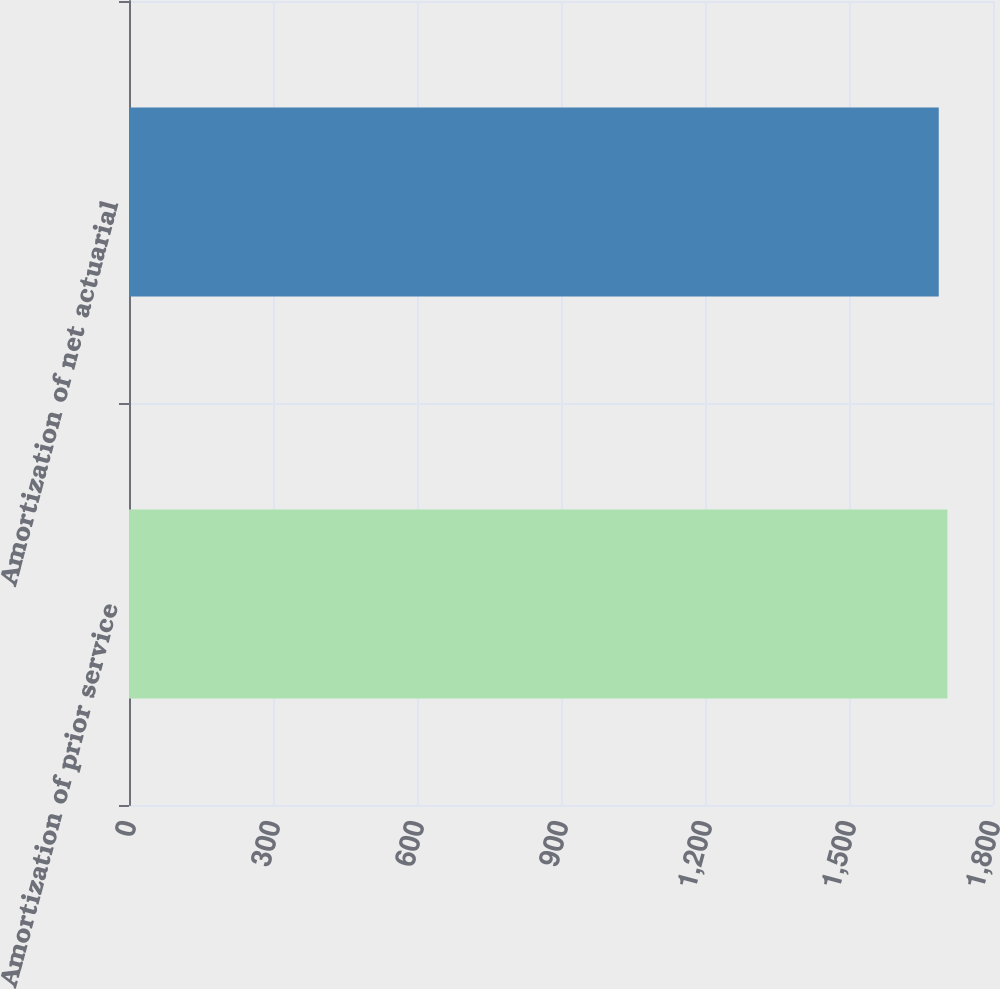<chart> <loc_0><loc_0><loc_500><loc_500><bar_chart><fcel>Amortization of prior service<fcel>Amortization of net actuarial<nl><fcel>1705<fcel>1687<nl></chart> 